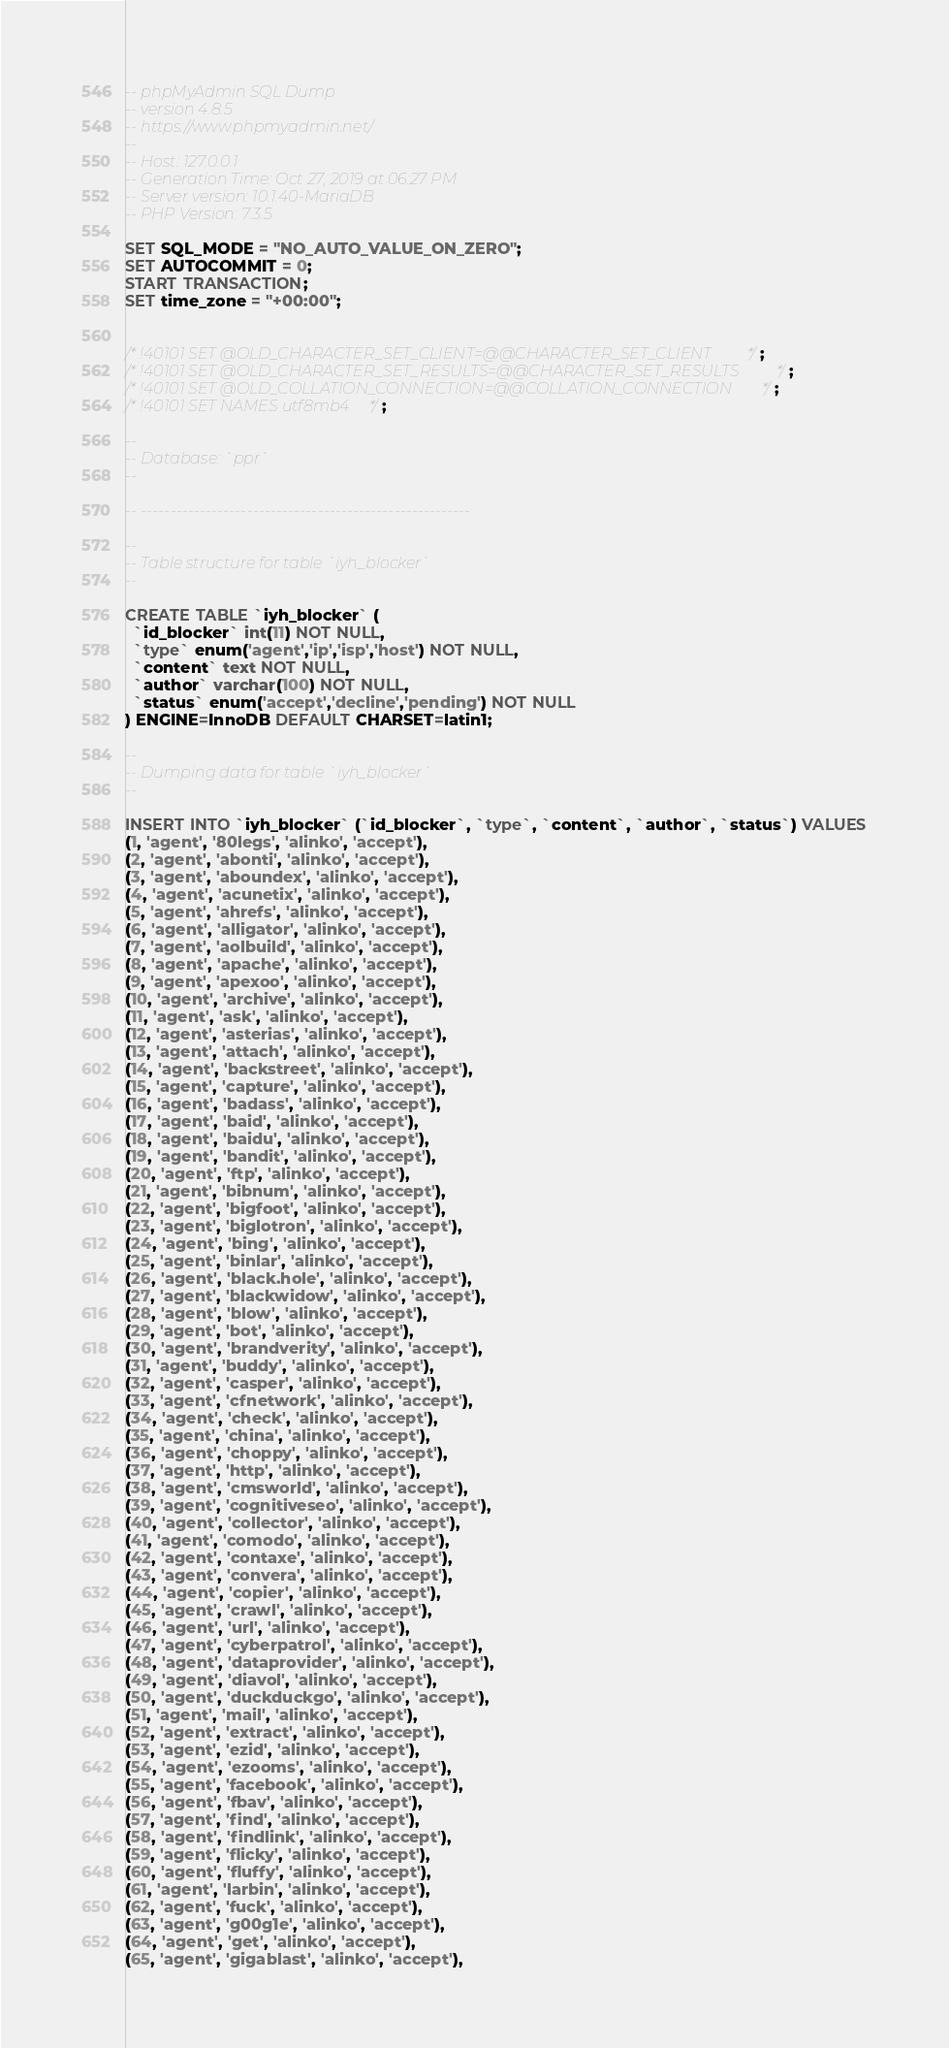<code> <loc_0><loc_0><loc_500><loc_500><_SQL_>-- phpMyAdmin SQL Dump
-- version 4.8.5
-- https://www.phpmyadmin.net/
--
-- Host: 127.0.0.1
-- Generation Time: Oct 27, 2019 at 06:27 PM
-- Server version: 10.1.40-MariaDB
-- PHP Version: 7.3.5

SET SQL_MODE = "NO_AUTO_VALUE_ON_ZERO";
SET AUTOCOMMIT = 0;
START TRANSACTION;
SET time_zone = "+00:00";


/*!40101 SET @OLD_CHARACTER_SET_CLIENT=@@CHARACTER_SET_CLIENT */;
/*!40101 SET @OLD_CHARACTER_SET_RESULTS=@@CHARACTER_SET_RESULTS */;
/*!40101 SET @OLD_COLLATION_CONNECTION=@@COLLATION_CONNECTION */;
/*!40101 SET NAMES utf8mb4 */;

--
-- Database: `ppr`
--

-- --------------------------------------------------------

--
-- Table structure for table `iyh_blocker`
--

CREATE TABLE `iyh_blocker` (
  `id_blocker` int(11) NOT NULL,
  `type` enum('agent','ip','isp','host') NOT NULL,
  `content` text NOT NULL,
  `author` varchar(100) NOT NULL,
  `status` enum('accept','decline','pending') NOT NULL
) ENGINE=InnoDB DEFAULT CHARSET=latin1;

--
-- Dumping data for table `iyh_blocker`
--

INSERT INTO `iyh_blocker` (`id_blocker`, `type`, `content`, `author`, `status`) VALUES
(1, 'agent', '80legs', 'alinko', 'accept'),
(2, 'agent', 'abonti', 'alinko', 'accept'),
(3, 'agent', 'aboundex', 'alinko', 'accept'),
(4, 'agent', 'acunetix', 'alinko', 'accept'),
(5, 'agent', 'ahrefs', 'alinko', 'accept'),
(6, 'agent', 'alligator', 'alinko', 'accept'),
(7, 'agent', 'aolbuild', 'alinko', 'accept'),
(8, 'agent', 'apache', 'alinko', 'accept'),
(9, 'agent', 'apexoo', 'alinko', 'accept'),
(10, 'agent', 'archive', 'alinko', 'accept'),
(11, 'agent', 'ask', 'alinko', 'accept'),
(12, 'agent', 'asterias', 'alinko', 'accept'),
(13, 'agent', 'attach', 'alinko', 'accept'),
(14, 'agent', 'backstreet', 'alinko', 'accept'),
(15, 'agent', 'capture', 'alinko', 'accept'),
(16, 'agent', 'badass', 'alinko', 'accept'),
(17, 'agent', 'baid', 'alinko', 'accept'),
(18, 'agent', 'baidu', 'alinko', 'accept'),
(19, 'agent', 'bandit', 'alinko', 'accept'),
(20, 'agent', 'ftp', 'alinko', 'accept'),
(21, 'agent', 'bibnum', 'alinko', 'accept'),
(22, 'agent', 'bigfoot', 'alinko', 'accept'),
(23, 'agent', 'biglotron', 'alinko', 'accept'),
(24, 'agent', 'bing', 'alinko', 'accept'),
(25, 'agent', 'binlar', 'alinko', 'accept'),
(26, 'agent', 'black.hole', 'alinko', 'accept'),
(27, 'agent', 'blackwidow', 'alinko', 'accept'),
(28, 'agent', 'blow', 'alinko', 'accept'),
(29, 'agent', 'bot', 'alinko', 'accept'),
(30, 'agent', 'brandverity', 'alinko', 'accept'),
(31, 'agent', 'buddy', 'alinko', 'accept'),
(32, 'agent', 'casper', 'alinko', 'accept'),
(33, 'agent', 'cfnetwork', 'alinko', 'accept'),
(34, 'agent', 'check', 'alinko', 'accept'),
(35, 'agent', 'china', 'alinko', 'accept'),
(36, 'agent', 'choppy', 'alinko', 'accept'),
(37, 'agent', 'http', 'alinko', 'accept'),
(38, 'agent', 'cmsworld', 'alinko', 'accept'),
(39, 'agent', 'cognitiveseo', 'alinko', 'accept'),
(40, 'agent', 'collector', 'alinko', 'accept'),
(41, 'agent', 'comodo', 'alinko', 'accept'),
(42, 'agent', 'contaxe', 'alinko', 'accept'),
(43, 'agent', 'convera', 'alinko', 'accept'),
(44, 'agent', 'copier', 'alinko', 'accept'),
(45, 'agent', 'crawl', 'alinko', 'accept'),
(46, 'agent', 'url', 'alinko', 'accept'),
(47, 'agent', 'cyberpatrol', 'alinko', 'accept'),
(48, 'agent', 'dataprovider', 'alinko', 'accept'),
(49, 'agent', 'diavol', 'alinko', 'accept'),
(50, 'agent', 'duckduckgo', 'alinko', 'accept'),
(51, 'agent', 'mail', 'alinko', 'accept'),
(52, 'agent', 'extract', 'alinko', 'accept'),
(53, 'agent', 'ezid', 'alinko', 'accept'),
(54, 'agent', 'ezooms', 'alinko', 'accept'),
(55, 'agent', 'facebook', 'alinko', 'accept'),
(56, 'agent', 'fbav', 'alinko', 'accept'),
(57, 'agent', 'find', 'alinko', 'accept'),
(58, 'agent', 'findlink', 'alinko', 'accept'),
(59, 'agent', 'flicky', 'alinko', 'accept'),
(60, 'agent', 'fluffy', 'alinko', 'accept'),
(61, 'agent', 'larbin', 'alinko', 'accept'),
(62, 'agent', 'fuck', 'alinko', 'accept'),
(63, 'agent', 'g00g1e', 'alinko', 'accept'),
(64, 'agent', 'get', 'alinko', 'accept'),
(65, 'agent', 'gigablast', 'alinko', 'accept'),</code> 